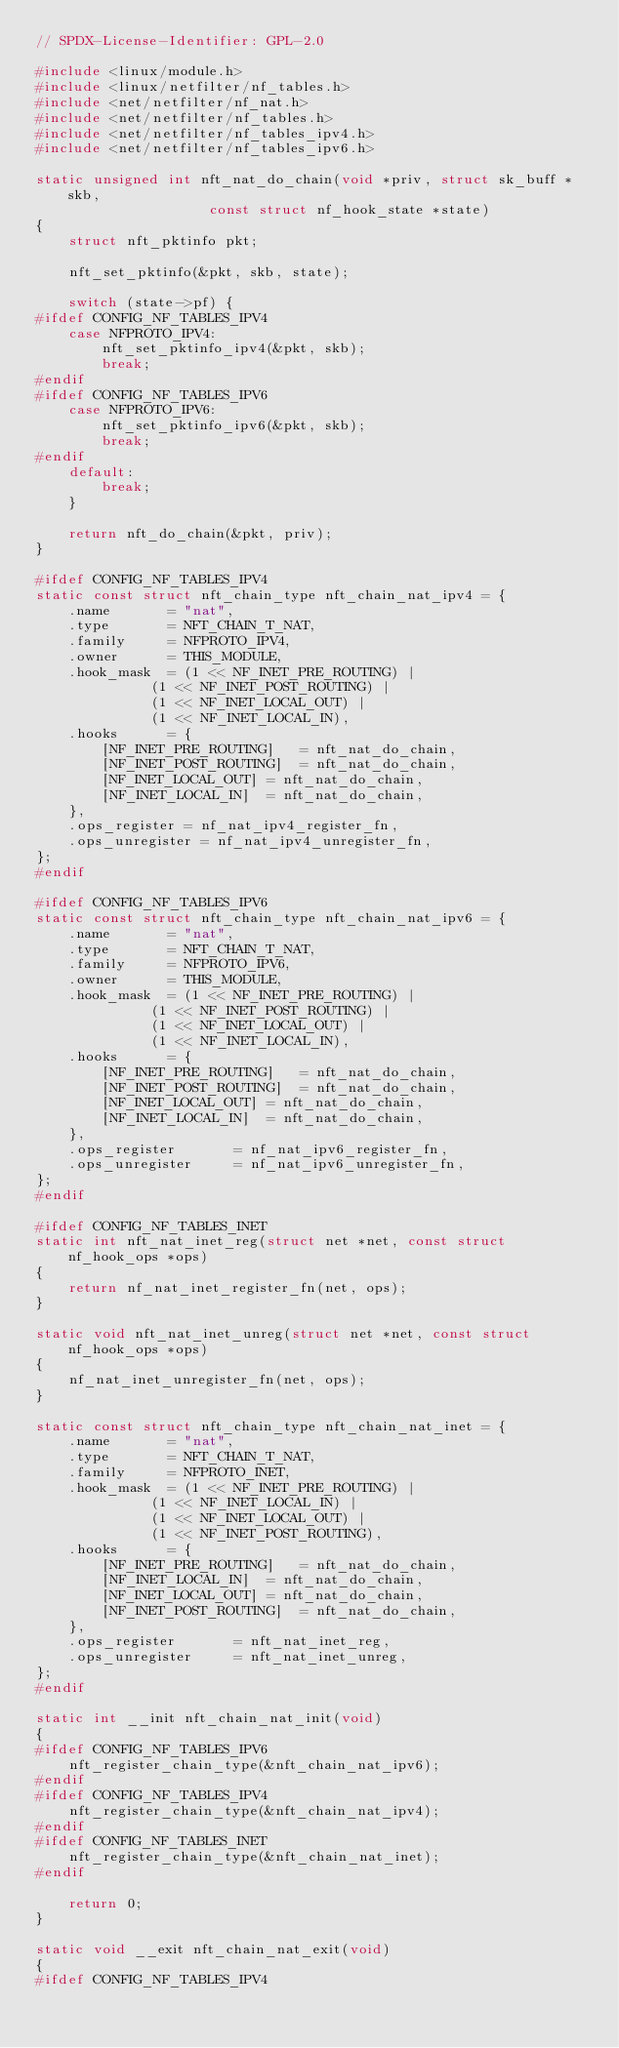Convert code to text. <code><loc_0><loc_0><loc_500><loc_500><_C_>// SPDX-License-Identifier: GPL-2.0

#include <linux/module.h>
#include <linux/netfilter/nf_tables.h>
#include <net/netfilter/nf_nat.h>
#include <net/netfilter/nf_tables.h>
#include <net/netfilter/nf_tables_ipv4.h>
#include <net/netfilter/nf_tables_ipv6.h>

static unsigned int nft_nat_do_chain(void *priv, struct sk_buff *skb,
				     const struct nf_hook_state *state)
{
	struct nft_pktinfo pkt;

	nft_set_pktinfo(&pkt, skb, state);

	switch (state->pf) {
#ifdef CONFIG_NF_TABLES_IPV4
	case NFPROTO_IPV4:
		nft_set_pktinfo_ipv4(&pkt, skb);
		break;
#endif
#ifdef CONFIG_NF_TABLES_IPV6
	case NFPROTO_IPV6:
		nft_set_pktinfo_ipv6(&pkt, skb);
		break;
#endif
	default:
		break;
	}

	return nft_do_chain(&pkt, priv);
}

#ifdef CONFIG_NF_TABLES_IPV4
static const struct nft_chain_type nft_chain_nat_ipv4 = {
	.name		= "nat",
	.type		= NFT_CHAIN_T_NAT,
	.family		= NFPROTO_IPV4,
	.owner		= THIS_MODULE,
	.hook_mask	= (1 << NF_INET_PRE_ROUTING) |
			  (1 << NF_INET_POST_ROUTING) |
			  (1 << NF_INET_LOCAL_OUT) |
			  (1 << NF_INET_LOCAL_IN),
	.hooks		= {
		[NF_INET_PRE_ROUTING]	= nft_nat_do_chain,
		[NF_INET_POST_ROUTING]	= nft_nat_do_chain,
		[NF_INET_LOCAL_OUT]	= nft_nat_do_chain,
		[NF_INET_LOCAL_IN]	= nft_nat_do_chain,
	},
	.ops_register = nf_nat_ipv4_register_fn,
	.ops_unregister = nf_nat_ipv4_unregister_fn,
};
#endif

#ifdef CONFIG_NF_TABLES_IPV6
static const struct nft_chain_type nft_chain_nat_ipv6 = {
	.name		= "nat",
	.type		= NFT_CHAIN_T_NAT,
	.family		= NFPROTO_IPV6,
	.owner		= THIS_MODULE,
	.hook_mask	= (1 << NF_INET_PRE_ROUTING) |
			  (1 << NF_INET_POST_ROUTING) |
			  (1 << NF_INET_LOCAL_OUT) |
			  (1 << NF_INET_LOCAL_IN),
	.hooks		= {
		[NF_INET_PRE_ROUTING]	= nft_nat_do_chain,
		[NF_INET_POST_ROUTING]	= nft_nat_do_chain,
		[NF_INET_LOCAL_OUT]	= nft_nat_do_chain,
		[NF_INET_LOCAL_IN]	= nft_nat_do_chain,
	},
	.ops_register		= nf_nat_ipv6_register_fn,
	.ops_unregister		= nf_nat_ipv6_unregister_fn,
};
#endif

#ifdef CONFIG_NF_TABLES_INET
static int nft_nat_inet_reg(struct net *net, const struct nf_hook_ops *ops)
{
	return nf_nat_inet_register_fn(net, ops);
}

static void nft_nat_inet_unreg(struct net *net, const struct nf_hook_ops *ops)
{
	nf_nat_inet_unregister_fn(net, ops);
}

static const struct nft_chain_type nft_chain_nat_inet = {
	.name		= "nat",
	.type		= NFT_CHAIN_T_NAT,
	.family		= NFPROTO_INET,
	.hook_mask	= (1 << NF_INET_PRE_ROUTING) |
			  (1 << NF_INET_LOCAL_IN) |
			  (1 << NF_INET_LOCAL_OUT) |
			  (1 << NF_INET_POST_ROUTING),
	.hooks		= {
		[NF_INET_PRE_ROUTING]	= nft_nat_do_chain,
		[NF_INET_LOCAL_IN]	= nft_nat_do_chain,
		[NF_INET_LOCAL_OUT]	= nft_nat_do_chain,
		[NF_INET_POST_ROUTING]	= nft_nat_do_chain,
	},
	.ops_register		= nft_nat_inet_reg,
	.ops_unregister		= nft_nat_inet_unreg,
};
#endif

static int __init nft_chain_nat_init(void)
{
#ifdef CONFIG_NF_TABLES_IPV6
	nft_register_chain_type(&nft_chain_nat_ipv6);
#endif
#ifdef CONFIG_NF_TABLES_IPV4
	nft_register_chain_type(&nft_chain_nat_ipv4);
#endif
#ifdef CONFIG_NF_TABLES_INET
	nft_register_chain_type(&nft_chain_nat_inet);
#endif

	return 0;
}

static void __exit nft_chain_nat_exit(void)
{
#ifdef CONFIG_NF_TABLES_IPV4</code> 